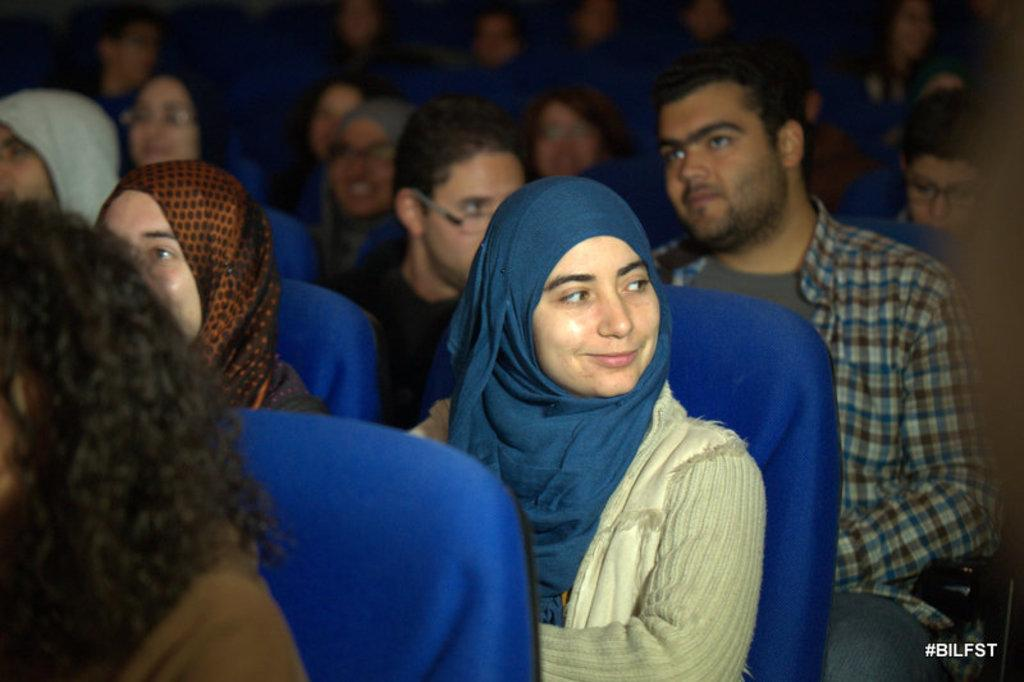How many people are in the image? There is a group of persons in the image. What are the persons doing in the image? The persons are sitting on chairs. Is there any text visible in the image? Yes, there is some text visible in the bottom right corner of the image. What type of pain is the governor experiencing in the image? There is no governor or any indication of pain present in the image. 